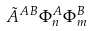<formula> <loc_0><loc_0><loc_500><loc_500>\tilde { A } ^ { A B } \Phi _ { n } ^ { A } \Phi _ { m } ^ { B }</formula> 